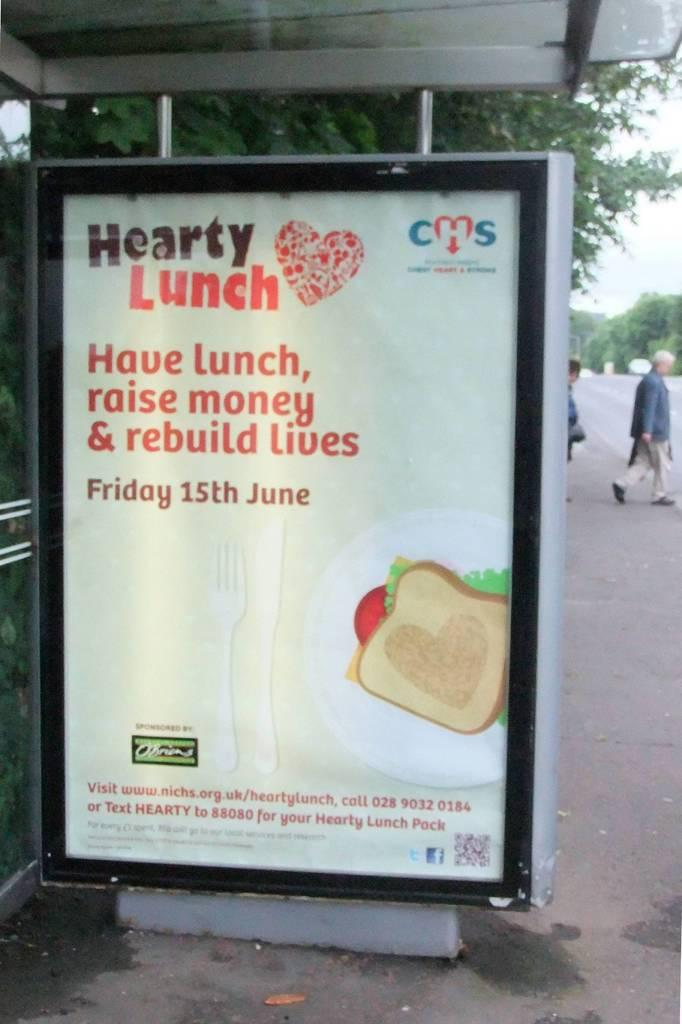<image>
Present a compact description of the photo's key features. A large sign is on the sidewalk and advertises a fundraiser on June 15th. 